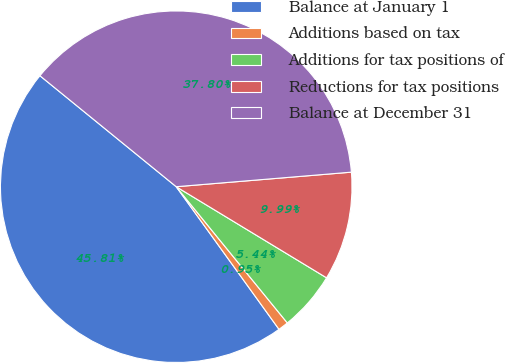Convert chart. <chart><loc_0><loc_0><loc_500><loc_500><pie_chart><fcel>Balance at January 1<fcel>Additions based on tax<fcel>Additions for tax positions of<fcel>Reductions for tax positions<fcel>Balance at December 31<nl><fcel>45.81%<fcel>0.95%<fcel>5.44%<fcel>9.99%<fcel>37.8%<nl></chart> 